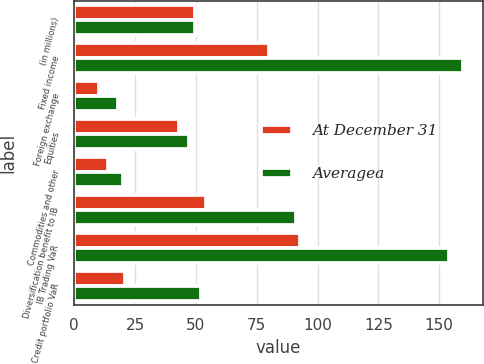Convert chart to OTSL. <chart><loc_0><loc_0><loc_500><loc_500><stacked_bar_chart><ecel><fcel>(in millions)<fcel>Fixed income<fcel>Foreign exchange<fcel>Equities<fcel>Commodities and other<fcel>Diversification benefit to IB<fcel>IB Trading VaR<fcel>Credit portfolio VaR<nl><fcel>At December 31<fcel>49.5<fcel>80<fcel>10<fcel>43<fcel>14<fcel>54<fcel>93<fcel>21<nl><fcel>Averagea<fcel>49.5<fcel>160<fcel>18<fcel>47<fcel>20<fcel>91<fcel>154<fcel>52<nl></chart> 